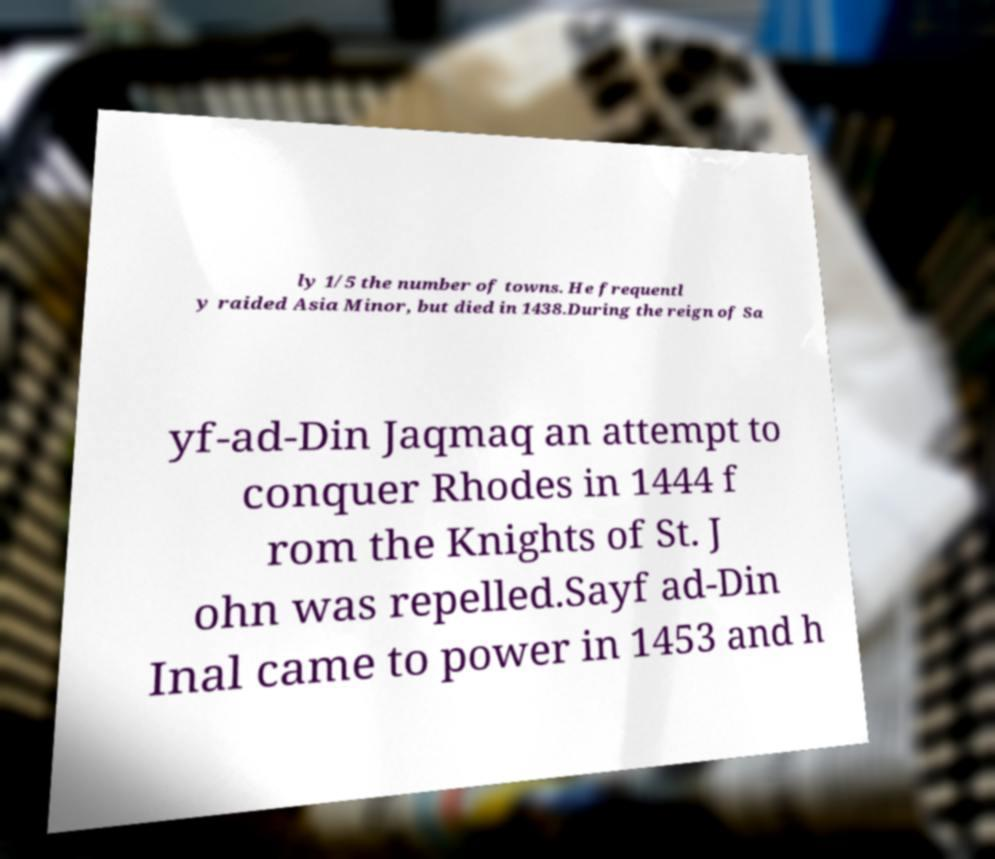Can you read and provide the text displayed in the image?This photo seems to have some interesting text. Can you extract and type it out for me? ly 1/5 the number of towns. He frequentl y raided Asia Minor, but died in 1438.During the reign of Sa yf-ad-Din Jaqmaq an attempt to conquer Rhodes in 1444 f rom the Knights of St. J ohn was repelled.Sayf ad-Din Inal came to power in 1453 and h 